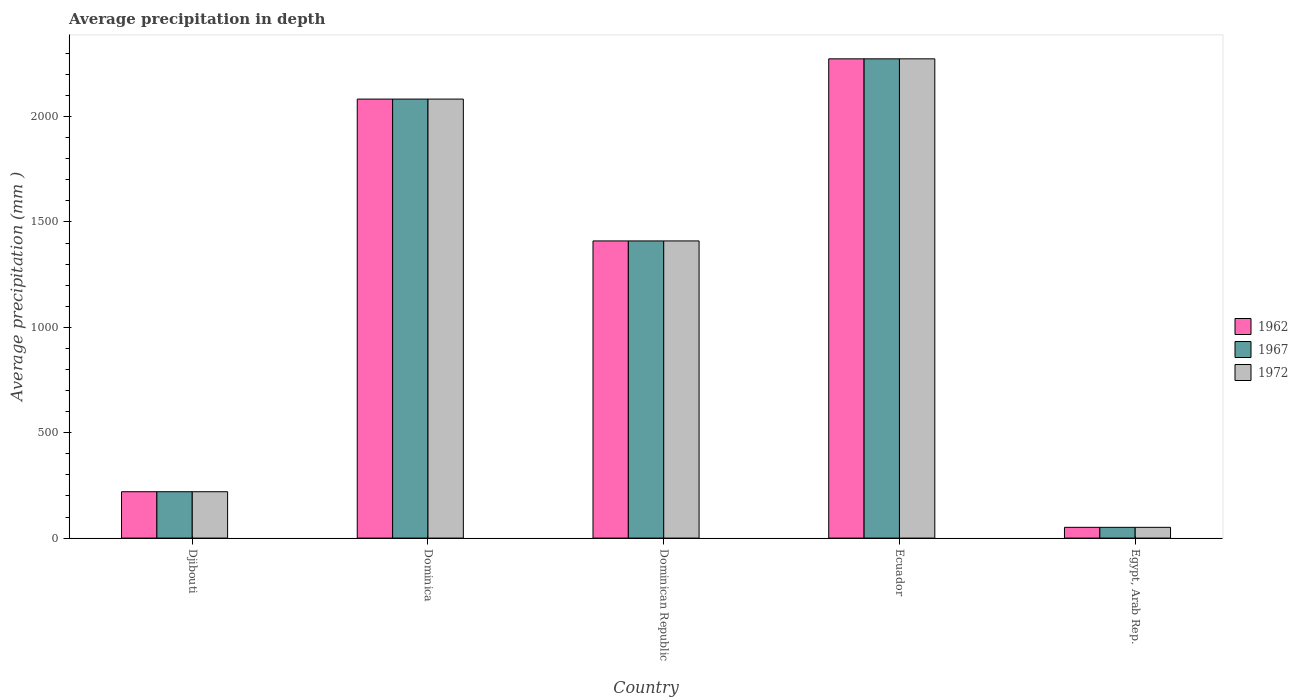How many different coloured bars are there?
Your response must be concise. 3. How many bars are there on the 2nd tick from the right?
Provide a succinct answer. 3. What is the label of the 2nd group of bars from the left?
Offer a very short reply. Dominica. What is the average precipitation in 1967 in Dominican Republic?
Offer a terse response. 1410. Across all countries, what is the maximum average precipitation in 1967?
Keep it short and to the point. 2274. In which country was the average precipitation in 1962 maximum?
Offer a terse response. Ecuador. In which country was the average precipitation in 1972 minimum?
Make the answer very short. Egypt, Arab Rep. What is the total average precipitation in 1972 in the graph?
Provide a short and direct response. 6038. What is the difference between the average precipitation in 1972 in Dominican Republic and that in Egypt, Arab Rep.?
Offer a very short reply. 1359. What is the difference between the average precipitation in 1967 in Ecuador and the average precipitation in 1972 in Egypt, Arab Rep.?
Your answer should be compact. 2223. What is the average average precipitation in 1967 per country?
Make the answer very short. 1207.6. What is the ratio of the average precipitation in 1967 in Dominica to that in Dominican Republic?
Ensure brevity in your answer.  1.48. Is the difference between the average precipitation in 1962 in Dominican Republic and Ecuador greater than the difference between the average precipitation in 1967 in Dominican Republic and Ecuador?
Keep it short and to the point. No. What is the difference between the highest and the second highest average precipitation in 1972?
Offer a terse response. 191. What is the difference between the highest and the lowest average precipitation in 1962?
Provide a succinct answer. 2223. In how many countries, is the average precipitation in 1972 greater than the average average precipitation in 1972 taken over all countries?
Provide a succinct answer. 3. Is the sum of the average precipitation in 1972 in Ecuador and Egypt, Arab Rep. greater than the maximum average precipitation in 1962 across all countries?
Your answer should be compact. Yes. What does the 2nd bar from the right in Djibouti represents?
Your answer should be compact. 1967. How many bars are there?
Give a very brief answer. 15. Are all the bars in the graph horizontal?
Provide a short and direct response. No. Are the values on the major ticks of Y-axis written in scientific E-notation?
Provide a succinct answer. No. Does the graph contain any zero values?
Keep it short and to the point. No. Where does the legend appear in the graph?
Your answer should be compact. Center right. How many legend labels are there?
Ensure brevity in your answer.  3. How are the legend labels stacked?
Keep it short and to the point. Vertical. What is the title of the graph?
Provide a short and direct response. Average precipitation in depth. Does "2002" appear as one of the legend labels in the graph?
Keep it short and to the point. No. What is the label or title of the Y-axis?
Keep it short and to the point. Average precipitation (mm ). What is the Average precipitation (mm ) in 1962 in Djibouti?
Offer a very short reply. 220. What is the Average precipitation (mm ) of 1967 in Djibouti?
Ensure brevity in your answer.  220. What is the Average precipitation (mm ) of 1972 in Djibouti?
Offer a very short reply. 220. What is the Average precipitation (mm ) in 1962 in Dominica?
Give a very brief answer. 2083. What is the Average precipitation (mm ) in 1967 in Dominica?
Offer a very short reply. 2083. What is the Average precipitation (mm ) in 1972 in Dominica?
Make the answer very short. 2083. What is the Average precipitation (mm ) in 1962 in Dominican Republic?
Provide a short and direct response. 1410. What is the Average precipitation (mm ) of 1967 in Dominican Republic?
Your response must be concise. 1410. What is the Average precipitation (mm ) of 1972 in Dominican Republic?
Keep it short and to the point. 1410. What is the Average precipitation (mm ) in 1962 in Ecuador?
Your response must be concise. 2274. What is the Average precipitation (mm ) in 1967 in Ecuador?
Offer a terse response. 2274. What is the Average precipitation (mm ) of 1972 in Ecuador?
Your response must be concise. 2274. What is the Average precipitation (mm ) in 1972 in Egypt, Arab Rep.?
Your response must be concise. 51. Across all countries, what is the maximum Average precipitation (mm ) in 1962?
Give a very brief answer. 2274. Across all countries, what is the maximum Average precipitation (mm ) in 1967?
Offer a very short reply. 2274. Across all countries, what is the maximum Average precipitation (mm ) in 1972?
Make the answer very short. 2274. Across all countries, what is the minimum Average precipitation (mm ) in 1962?
Your answer should be compact. 51. What is the total Average precipitation (mm ) of 1962 in the graph?
Your answer should be very brief. 6038. What is the total Average precipitation (mm ) of 1967 in the graph?
Your answer should be compact. 6038. What is the total Average precipitation (mm ) in 1972 in the graph?
Provide a succinct answer. 6038. What is the difference between the Average precipitation (mm ) of 1962 in Djibouti and that in Dominica?
Give a very brief answer. -1863. What is the difference between the Average precipitation (mm ) of 1967 in Djibouti and that in Dominica?
Provide a short and direct response. -1863. What is the difference between the Average precipitation (mm ) of 1972 in Djibouti and that in Dominica?
Ensure brevity in your answer.  -1863. What is the difference between the Average precipitation (mm ) of 1962 in Djibouti and that in Dominican Republic?
Your answer should be very brief. -1190. What is the difference between the Average precipitation (mm ) in 1967 in Djibouti and that in Dominican Republic?
Ensure brevity in your answer.  -1190. What is the difference between the Average precipitation (mm ) of 1972 in Djibouti and that in Dominican Republic?
Offer a very short reply. -1190. What is the difference between the Average precipitation (mm ) in 1962 in Djibouti and that in Ecuador?
Make the answer very short. -2054. What is the difference between the Average precipitation (mm ) of 1967 in Djibouti and that in Ecuador?
Provide a short and direct response. -2054. What is the difference between the Average precipitation (mm ) in 1972 in Djibouti and that in Ecuador?
Make the answer very short. -2054. What is the difference between the Average precipitation (mm ) of 1962 in Djibouti and that in Egypt, Arab Rep.?
Offer a terse response. 169. What is the difference between the Average precipitation (mm ) of 1967 in Djibouti and that in Egypt, Arab Rep.?
Offer a terse response. 169. What is the difference between the Average precipitation (mm ) in 1972 in Djibouti and that in Egypt, Arab Rep.?
Your response must be concise. 169. What is the difference between the Average precipitation (mm ) in 1962 in Dominica and that in Dominican Republic?
Offer a terse response. 673. What is the difference between the Average precipitation (mm ) in 1967 in Dominica and that in Dominican Republic?
Your answer should be compact. 673. What is the difference between the Average precipitation (mm ) in 1972 in Dominica and that in Dominican Republic?
Ensure brevity in your answer.  673. What is the difference between the Average precipitation (mm ) in 1962 in Dominica and that in Ecuador?
Offer a terse response. -191. What is the difference between the Average precipitation (mm ) in 1967 in Dominica and that in Ecuador?
Your response must be concise. -191. What is the difference between the Average precipitation (mm ) of 1972 in Dominica and that in Ecuador?
Make the answer very short. -191. What is the difference between the Average precipitation (mm ) of 1962 in Dominica and that in Egypt, Arab Rep.?
Your answer should be very brief. 2032. What is the difference between the Average precipitation (mm ) of 1967 in Dominica and that in Egypt, Arab Rep.?
Keep it short and to the point. 2032. What is the difference between the Average precipitation (mm ) of 1972 in Dominica and that in Egypt, Arab Rep.?
Ensure brevity in your answer.  2032. What is the difference between the Average precipitation (mm ) of 1962 in Dominican Republic and that in Ecuador?
Your response must be concise. -864. What is the difference between the Average precipitation (mm ) of 1967 in Dominican Republic and that in Ecuador?
Provide a short and direct response. -864. What is the difference between the Average precipitation (mm ) of 1972 in Dominican Republic and that in Ecuador?
Give a very brief answer. -864. What is the difference between the Average precipitation (mm ) of 1962 in Dominican Republic and that in Egypt, Arab Rep.?
Give a very brief answer. 1359. What is the difference between the Average precipitation (mm ) of 1967 in Dominican Republic and that in Egypt, Arab Rep.?
Keep it short and to the point. 1359. What is the difference between the Average precipitation (mm ) of 1972 in Dominican Republic and that in Egypt, Arab Rep.?
Your answer should be very brief. 1359. What is the difference between the Average precipitation (mm ) in 1962 in Ecuador and that in Egypt, Arab Rep.?
Your answer should be very brief. 2223. What is the difference between the Average precipitation (mm ) in 1967 in Ecuador and that in Egypt, Arab Rep.?
Ensure brevity in your answer.  2223. What is the difference between the Average precipitation (mm ) of 1972 in Ecuador and that in Egypt, Arab Rep.?
Provide a short and direct response. 2223. What is the difference between the Average precipitation (mm ) of 1962 in Djibouti and the Average precipitation (mm ) of 1967 in Dominica?
Give a very brief answer. -1863. What is the difference between the Average precipitation (mm ) of 1962 in Djibouti and the Average precipitation (mm ) of 1972 in Dominica?
Your answer should be very brief. -1863. What is the difference between the Average precipitation (mm ) of 1967 in Djibouti and the Average precipitation (mm ) of 1972 in Dominica?
Offer a terse response. -1863. What is the difference between the Average precipitation (mm ) of 1962 in Djibouti and the Average precipitation (mm ) of 1967 in Dominican Republic?
Provide a short and direct response. -1190. What is the difference between the Average precipitation (mm ) of 1962 in Djibouti and the Average precipitation (mm ) of 1972 in Dominican Republic?
Provide a short and direct response. -1190. What is the difference between the Average precipitation (mm ) of 1967 in Djibouti and the Average precipitation (mm ) of 1972 in Dominican Republic?
Offer a terse response. -1190. What is the difference between the Average precipitation (mm ) in 1962 in Djibouti and the Average precipitation (mm ) in 1967 in Ecuador?
Provide a succinct answer. -2054. What is the difference between the Average precipitation (mm ) in 1962 in Djibouti and the Average precipitation (mm ) in 1972 in Ecuador?
Your response must be concise. -2054. What is the difference between the Average precipitation (mm ) of 1967 in Djibouti and the Average precipitation (mm ) of 1972 in Ecuador?
Offer a very short reply. -2054. What is the difference between the Average precipitation (mm ) in 1962 in Djibouti and the Average precipitation (mm ) in 1967 in Egypt, Arab Rep.?
Offer a very short reply. 169. What is the difference between the Average precipitation (mm ) in 1962 in Djibouti and the Average precipitation (mm ) in 1972 in Egypt, Arab Rep.?
Make the answer very short. 169. What is the difference between the Average precipitation (mm ) of 1967 in Djibouti and the Average precipitation (mm ) of 1972 in Egypt, Arab Rep.?
Provide a short and direct response. 169. What is the difference between the Average precipitation (mm ) in 1962 in Dominica and the Average precipitation (mm ) in 1967 in Dominican Republic?
Offer a terse response. 673. What is the difference between the Average precipitation (mm ) of 1962 in Dominica and the Average precipitation (mm ) of 1972 in Dominican Republic?
Ensure brevity in your answer.  673. What is the difference between the Average precipitation (mm ) in 1967 in Dominica and the Average precipitation (mm ) in 1972 in Dominican Republic?
Provide a short and direct response. 673. What is the difference between the Average precipitation (mm ) of 1962 in Dominica and the Average precipitation (mm ) of 1967 in Ecuador?
Offer a very short reply. -191. What is the difference between the Average precipitation (mm ) of 1962 in Dominica and the Average precipitation (mm ) of 1972 in Ecuador?
Your answer should be compact. -191. What is the difference between the Average precipitation (mm ) in 1967 in Dominica and the Average precipitation (mm ) in 1972 in Ecuador?
Provide a succinct answer. -191. What is the difference between the Average precipitation (mm ) of 1962 in Dominica and the Average precipitation (mm ) of 1967 in Egypt, Arab Rep.?
Provide a short and direct response. 2032. What is the difference between the Average precipitation (mm ) in 1962 in Dominica and the Average precipitation (mm ) in 1972 in Egypt, Arab Rep.?
Offer a terse response. 2032. What is the difference between the Average precipitation (mm ) in 1967 in Dominica and the Average precipitation (mm ) in 1972 in Egypt, Arab Rep.?
Offer a very short reply. 2032. What is the difference between the Average precipitation (mm ) of 1962 in Dominican Republic and the Average precipitation (mm ) of 1967 in Ecuador?
Offer a terse response. -864. What is the difference between the Average precipitation (mm ) in 1962 in Dominican Republic and the Average precipitation (mm ) in 1972 in Ecuador?
Your answer should be compact. -864. What is the difference between the Average precipitation (mm ) of 1967 in Dominican Republic and the Average precipitation (mm ) of 1972 in Ecuador?
Give a very brief answer. -864. What is the difference between the Average precipitation (mm ) of 1962 in Dominican Republic and the Average precipitation (mm ) of 1967 in Egypt, Arab Rep.?
Keep it short and to the point. 1359. What is the difference between the Average precipitation (mm ) in 1962 in Dominican Republic and the Average precipitation (mm ) in 1972 in Egypt, Arab Rep.?
Ensure brevity in your answer.  1359. What is the difference between the Average precipitation (mm ) in 1967 in Dominican Republic and the Average precipitation (mm ) in 1972 in Egypt, Arab Rep.?
Offer a terse response. 1359. What is the difference between the Average precipitation (mm ) of 1962 in Ecuador and the Average precipitation (mm ) of 1967 in Egypt, Arab Rep.?
Keep it short and to the point. 2223. What is the difference between the Average precipitation (mm ) of 1962 in Ecuador and the Average precipitation (mm ) of 1972 in Egypt, Arab Rep.?
Provide a succinct answer. 2223. What is the difference between the Average precipitation (mm ) of 1967 in Ecuador and the Average precipitation (mm ) of 1972 in Egypt, Arab Rep.?
Your answer should be compact. 2223. What is the average Average precipitation (mm ) of 1962 per country?
Give a very brief answer. 1207.6. What is the average Average precipitation (mm ) of 1967 per country?
Provide a succinct answer. 1207.6. What is the average Average precipitation (mm ) in 1972 per country?
Your answer should be very brief. 1207.6. What is the difference between the Average precipitation (mm ) in 1967 and Average precipitation (mm ) in 1972 in Djibouti?
Offer a very short reply. 0. What is the difference between the Average precipitation (mm ) in 1962 and Average precipitation (mm ) in 1967 in Dominica?
Your answer should be very brief. 0. What is the difference between the Average precipitation (mm ) of 1962 and Average precipitation (mm ) of 1972 in Dominica?
Your answer should be very brief. 0. What is the difference between the Average precipitation (mm ) in 1967 and Average precipitation (mm ) in 1972 in Dominica?
Provide a succinct answer. 0. What is the difference between the Average precipitation (mm ) in 1962 and Average precipitation (mm ) in 1967 in Dominican Republic?
Your response must be concise. 0. What is the difference between the Average precipitation (mm ) in 1962 and Average precipitation (mm ) in 1972 in Dominican Republic?
Provide a succinct answer. 0. What is the difference between the Average precipitation (mm ) in 1962 and Average precipitation (mm ) in 1967 in Ecuador?
Give a very brief answer. 0. What is the difference between the Average precipitation (mm ) in 1962 and Average precipitation (mm ) in 1972 in Ecuador?
Give a very brief answer. 0. What is the ratio of the Average precipitation (mm ) of 1962 in Djibouti to that in Dominica?
Your answer should be very brief. 0.11. What is the ratio of the Average precipitation (mm ) of 1967 in Djibouti to that in Dominica?
Provide a succinct answer. 0.11. What is the ratio of the Average precipitation (mm ) in 1972 in Djibouti to that in Dominica?
Keep it short and to the point. 0.11. What is the ratio of the Average precipitation (mm ) of 1962 in Djibouti to that in Dominican Republic?
Give a very brief answer. 0.16. What is the ratio of the Average precipitation (mm ) in 1967 in Djibouti to that in Dominican Republic?
Offer a very short reply. 0.16. What is the ratio of the Average precipitation (mm ) in 1972 in Djibouti to that in Dominican Republic?
Ensure brevity in your answer.  0.16. What is the ratio of the Average precipitation (mm ) in 1962 in Djibouti to that in Ecuador?
Offer a very short reply. 0.1. What is the ratio of the Average precipitation (mm ) in 1967 in Djibouti to that in Ecuador?
Ensure brevity in your answer.  0.1. What is the ratio of the Average precipitation (mm ) in 1972 in Djibouti to that in Ecuador?
Give a very brief answer. 0.1. What is the ratio of the Average precipitation (mm ) of 1962 in Djibouti to that in Egypt, Arab Rep.?
Keep it short and to the point. 4.31. What is the ratio of the Average precipitation (mm ) in 1967 in Djibouti to that in Egypt, Arab Rep.?
Your answer should be compact. 4.31. What is the ratio of the Average precipitation (mm ) in 1972 in Djibouti to that in Egypt, Arab Rep.?
Offer a very short reply. 4.31. What is the ratio of the Average precipitation (mm ) in 1962 in Dominica to that in Dominican Republic?
Your answer should be very brief. 1.48. What is the ratio of the Average precipitation (mm ) of 1967 in Dominica to that in Dominican Republic?
Give a very brief answer. 1.48. What is the ratio of the Average precipitation (mm ) of 1972 in Dominica to that in Dominican Republic?
Offer a very short reply. 1.48. What is the ratio of the Average precipitation (mm ) of 1962 in Dominica to that in Ecuador?
Make the answer very short. 0.92. What is the ratio of the Average precipitation (mm ) of 1967 in Dominica to that in Ecuador?
Offer a terse response. 0.92. What is the ratio of the Average precipitation (mm ) of 1972 in Dominica to that in Ecuador?
Provide a short and direct response. 0.92. What is the ratio of the Average precipitation (mm ) of 1962 in Dominica to that in Egypt, Arab Rep.?
Make the answer very short. 40.84. What is the ratio of the Average precipitation (mm ) of 1967 in Dominica to that in Egypt, Arab Rep.?
Provide a succinct answer. 40.84. What is the ratio of the Average precipitation (mm ) in 1972 in Dominica to that in Egypt, Arab Rep.?
Give a very brief answer. 40.84. What is the ratio of the Average precipitation (mm ) of 1962 in Dominican Republic to that in Ecuador?
Your answer should be very brief. 0.62. What is the ratio of the Average precipitation (mm ) in 1967 in Dominican Republic to that in Ecuador?
Your answer should be very brief. 0.62. What is the ratio of the Average precipitation (mm ) of 1972 in Dominican Republic to that in Ecuador?
Your answer should be compact. 0.62. What is the ratio of the Average precipitation (mm ) of 1962 in Dominican Republic to that in Egypt, Arab Rep.?
Provide a short and direct response. 27.65. What is the ratio of the Average precipitation (mm ) in 1967 in Dominican Republic to that in Egypt, Arab Rep.?
Your response must be concise. 27.65. What is the ratio of the Average precipitation (mm ) of 1972 in Dominican Republic to that in Egypt, Arab Rep.?
Offer a terse response. 27.65. What is the ratio of the Average precipitation (mm ) of 1962 in Ecuador to that in Egypt, Arab Rep.?
Provide a short and direct response. 44.59. What is the ratio of the Average precipitation (mm ) of 1967 in Ecuador to that in Egypt, Arab Rep.?
Make the answer very short. 44.59. What is the ratio of the Average precipitation (mm ) of 1972 in Ecuador to that in Egypt, Arab Rep.?
Offer a terse response. 44.59. What is the difference between the highest and the second highest Average precipitation (mm ) of 1962?
Offer a very short reply. 191. What is the difference between the highest and the second highest Average precipitation (mm ) of 1967?
Offer a terse response. 191. What is the difference between the highest and the second highest Average precipitation (mm ) in 1972?
Your response must be concise. 191. What is the difference between the highest and the lowest Average precipitation (mm ) of 1962?
Offer a terse response. 2223. What is the difference between the highest and the lowest Average precipitation (mm ) in 1967?
Offer a very short reply. 2223. What is the difference between the highest and the lowest Average precipitation (mm ) of 1972?
Provide a short and direct response. 2223. 